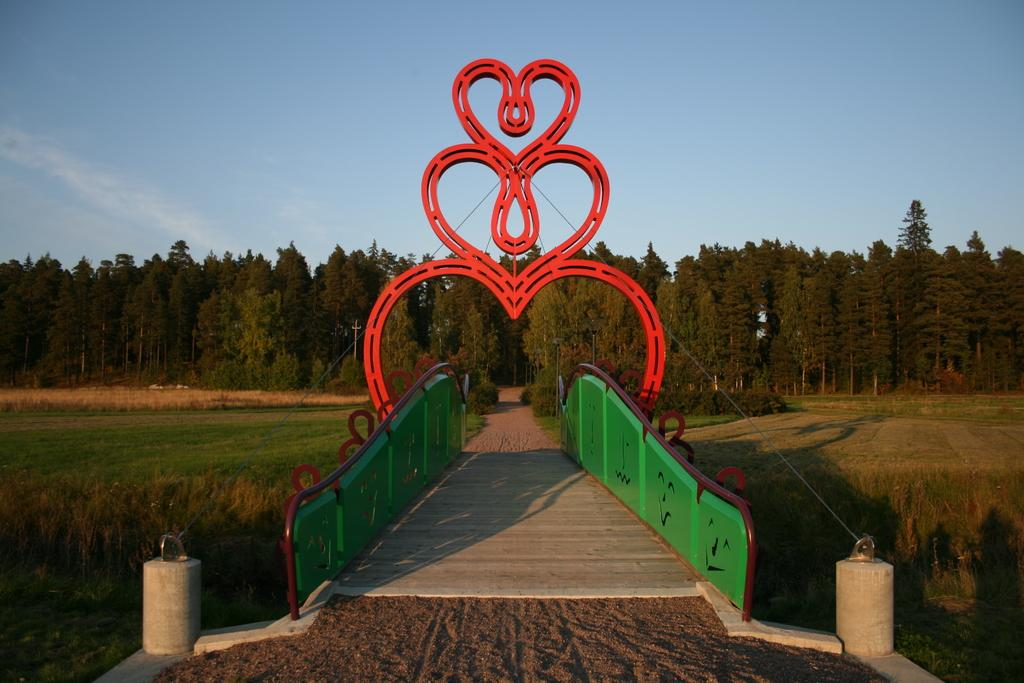What is the main structure in the middle of the picture? There is a bridge in the middle of the picture. What can be seen in the background of the picture? There are trees and the sky visible in the background of the picture. How many balls are being rubbed together in the image? There are no balls or rubbing actions present in the image. 